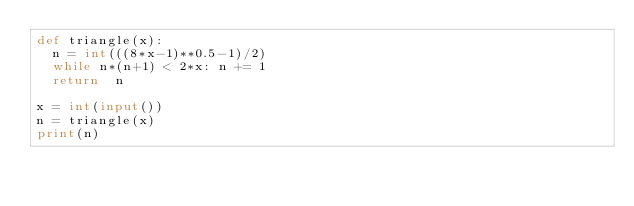Convert code to text. <code><loc_0><loc_0><loc_500><loc_500><_Python_>def triangle(x):
  n = int(((8*x-1)**0.5-1)/2)
  while n*(n+1) < 2*x: n += 1
  return  n
  
x = int(input())
n = triangle(x)
print(n) </code> 